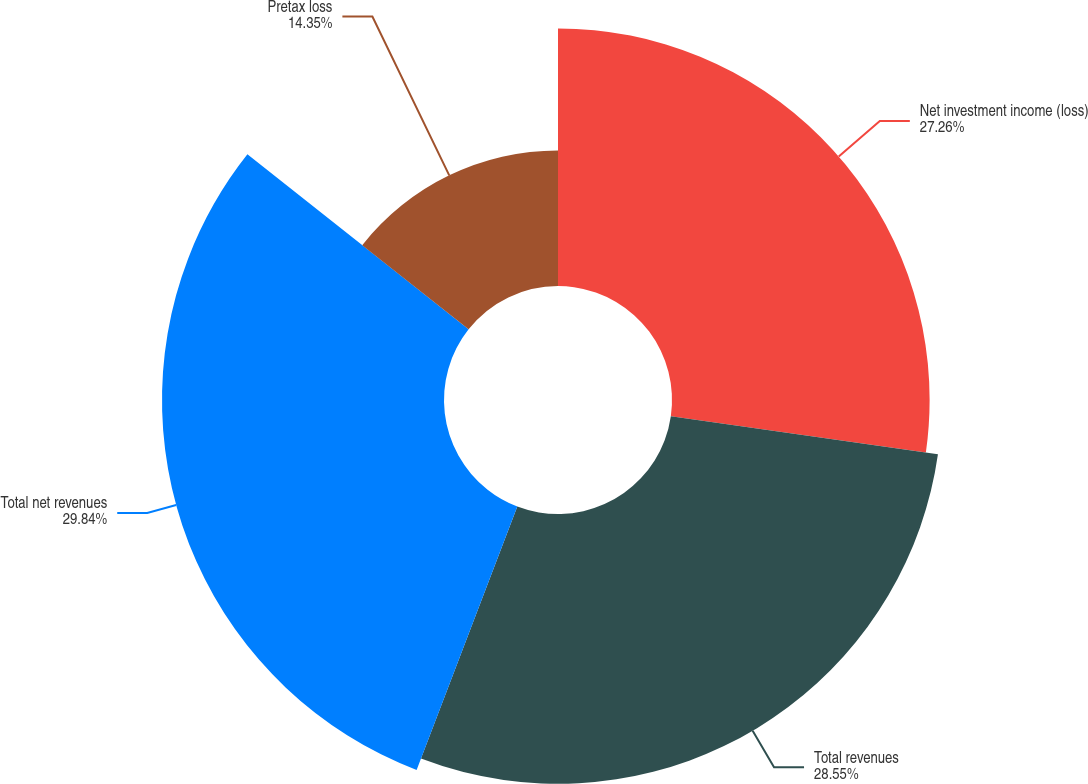Convert chart. <chart><loc_0><loc_0><loc_500><loc_500><pie_chart><fcel>Net investment income (loss)<fcel>Total revenues<fcel>Total net revenues<fcel>Pretax loss<nl><fcel>27.26%<fcel>28.55%<fcel>29.84%<fcel>14.35%<nl></chart> 